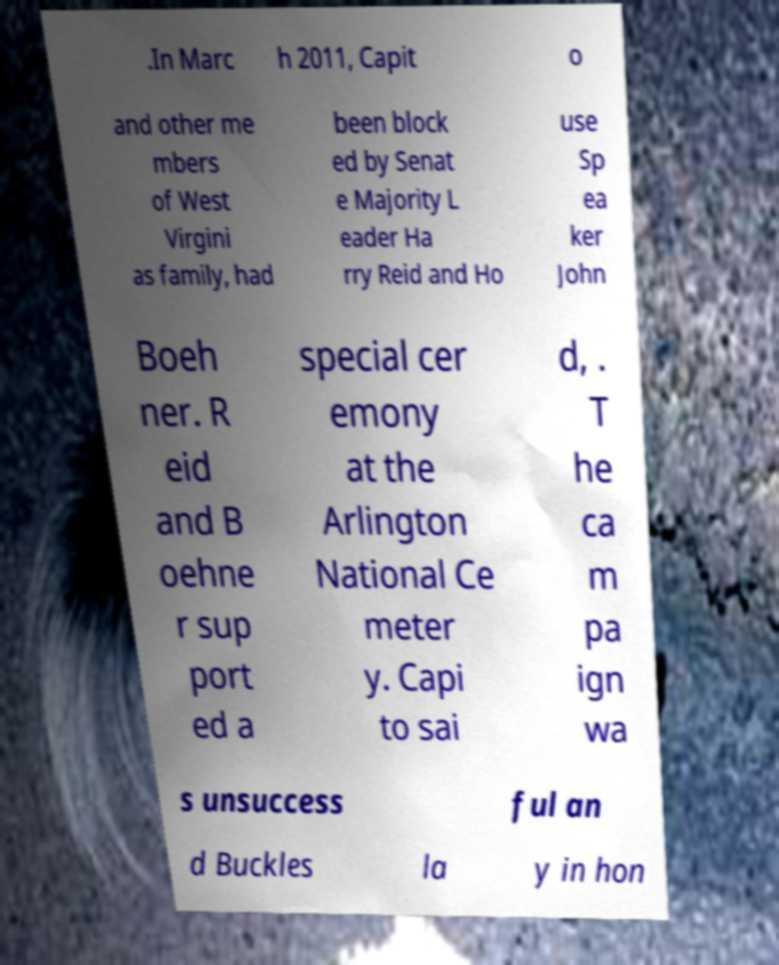Could you assist in decoding the text presented in this image and type it out clearly? .In Marc h 2011, Capit o and other me mbers of West Virgini as family, had been block ed by Senat e Majority L eader Ha rry Reid and Ho use Sp ea ker John Boeh ner. R eid and B oehne r sup port ed a special cer emony at the Arlington National Ce meter y. Capi to sai d, . T he ca m pa ign wa s unsuccess ful an d Buckles la y in hon 